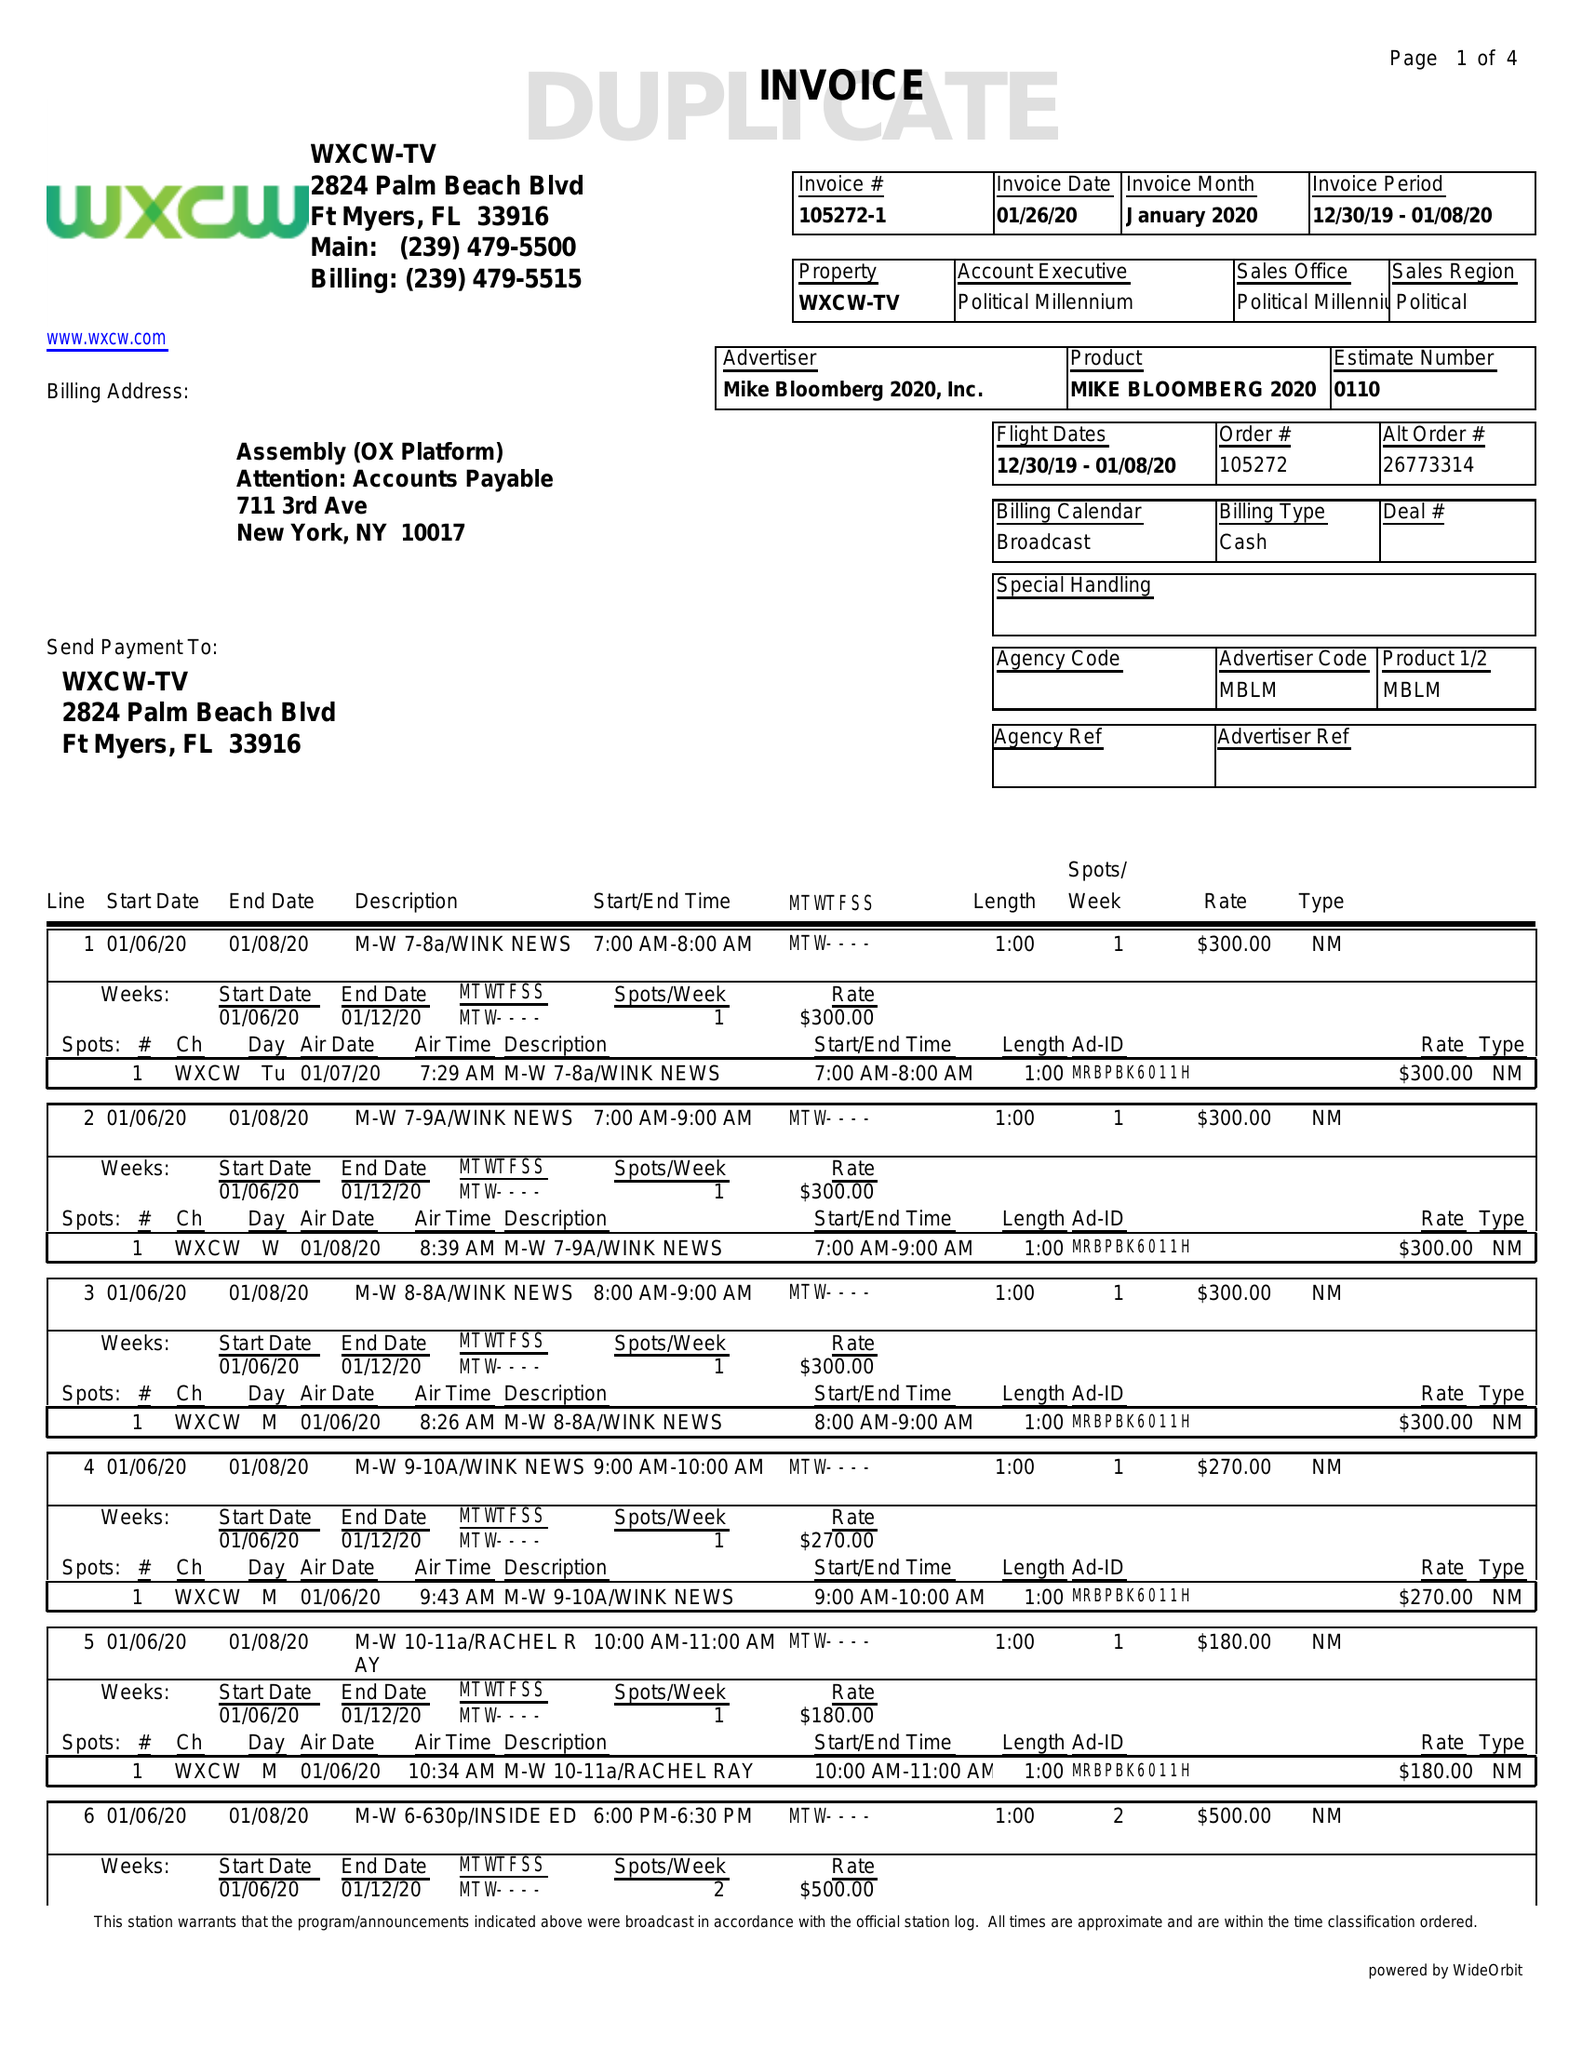What is the value for the gross_amount?
Answer the question using a single word or phrase. 17200.00 